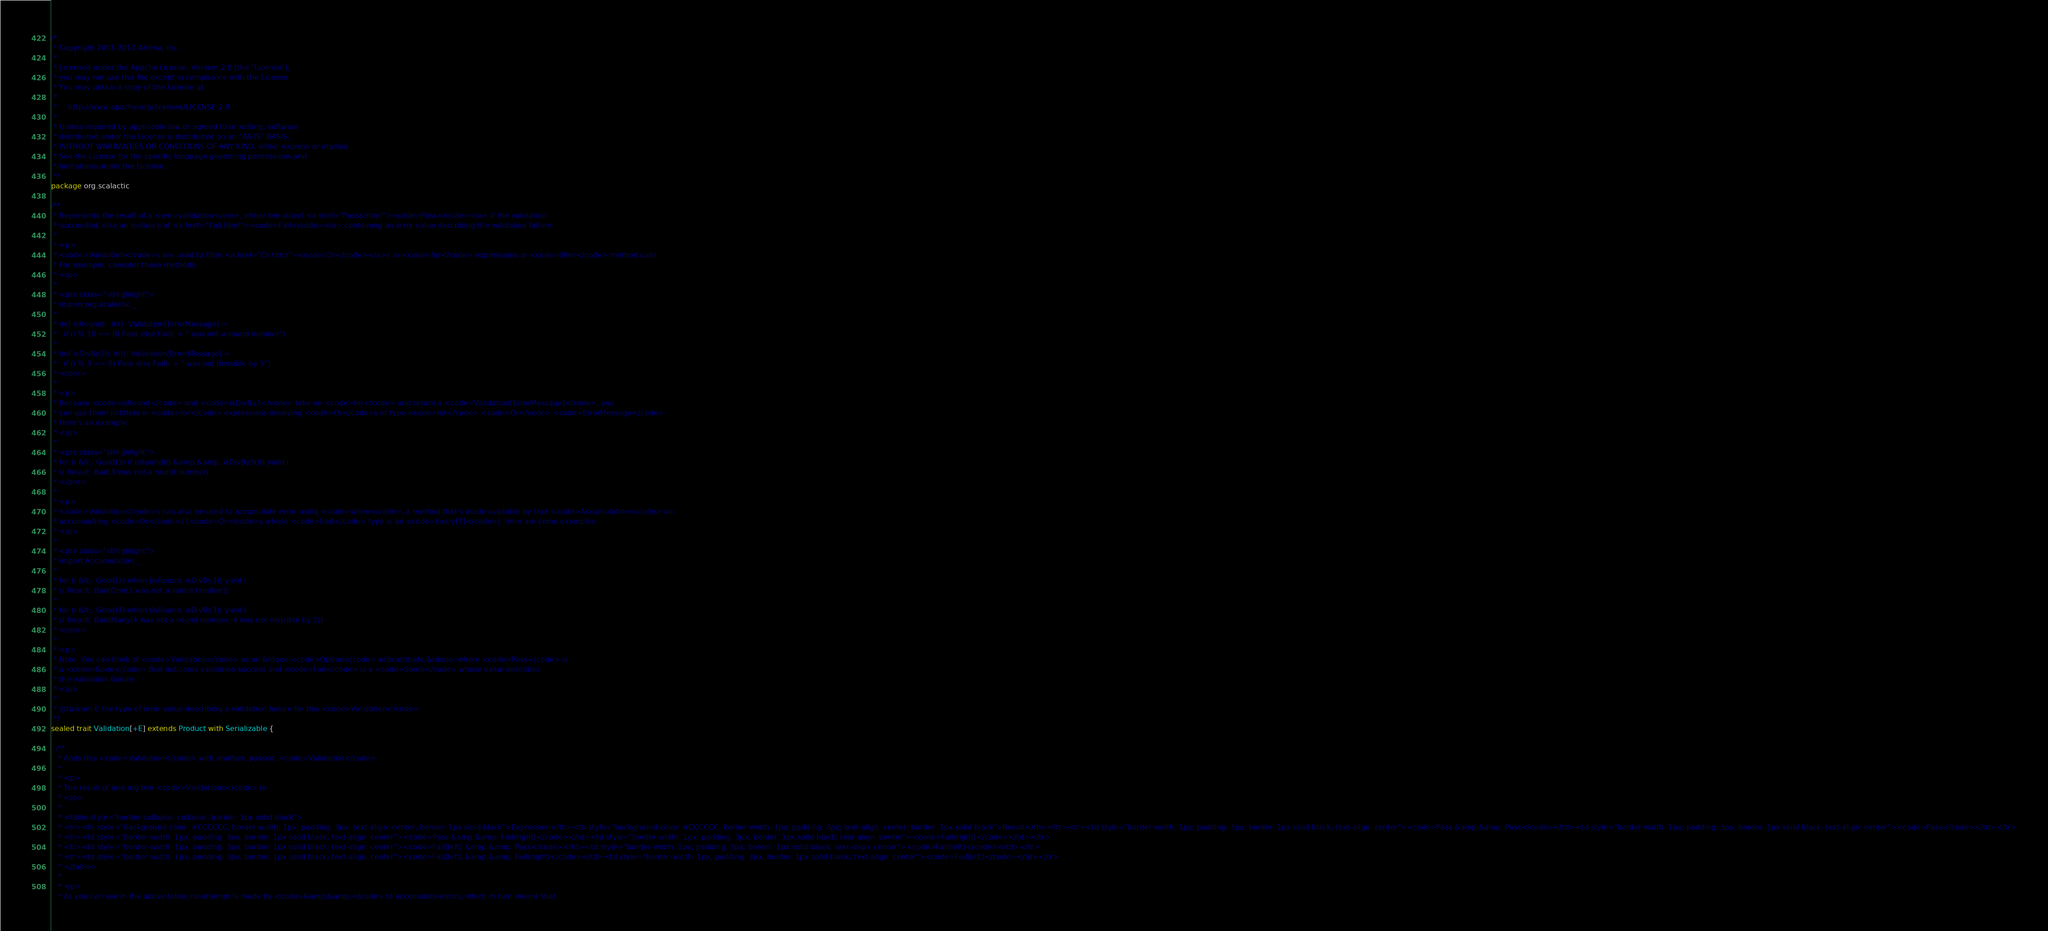<code> <loc_0><loc_0><loc_500><loc_500><_Scala_>/*
 * Copyright 2001-2013 Artima, Inc.
 *
 * Licensed under the Apache License, Version 2.0 (the "License");
 * you may not use this file except in compliance with the License.
 * You may obtain a copy of the License at
 *
 *     http://www.apache.org/licenses/LICENSE-2.0
 *
 * Unless required by applicable law or agreed to in writing, software
 * distributed under the License is distributed on an "AS IS" BASIS,
 * WITHOUT WARRANTIES OR CONDITIONS OF ANY KIND, either express or implied.
 * See the License for the specific language governing permissions and
 * limitations under the License.
 */
package org.scalactic

/**
 * Represents the result of a <em>validation</em>, either the object <a href="Pass$.html"><code>Pass</code></a> if the validation 
 * succeeded, else an instance of <a href="Fail.html"><code>Fail</code></a> containing an error value describing the validation failure.
 *
 * <p>
 * <code>Validation</code>s are used to filter <a href="Or.html"><code>Or</code></a>s in <code>for</code> expressions or <code>filter</code> method calls.
 * For example, consider these methods:
 * </p>
 *
 * <pre class="stHighlight">
 * import org.scalactic._
 *
 * def isRound(i: Int): Validation[ErrorMessage] =
 *   if (i % 10 == 0) Pass else Fail(i + " was not a round number")
 *
 * def isDivBy3(i: Int): Validation[ErrorMessage] =
 *   if (i % 3 == 0) Pass else Fail(i + " was not divisible by 3")
 * </pre>
 *
 * <p>
 * Because <code>isRound</code> and <code>isDivBy3</code> take an <code>Int</code> and return a <code>Validation[ErrorMessage]</code>, you
 * can use them in filters in <code>for</code> expressions involving <code>Or</code>s of type <code>Int</code> <code>Or</code> <code>ErrorMessage</code>.
 * Here's an example:
 * </p>
 *
 * <pre class="stHighlight">
 * for (i &lt;- Good(3) if isRound(i) &amp;&amp; isDivBy3(i)) yield i
 * // Result: Bad(3 was not a round number)
 * </pre>
 *
 * <p>
 * <code>Validation</code>s can also be used to accumulate error using <code>when</code>, a method that's made available by trait <code>Accumulation</code> on
 * accumualting <code>Or</code>s (<code>Or</code>s whose <code>Bad</code> type is an <code>Every[T]</code>). Here are some examples:
 * </p>
 *
 * <pre class="stHighlight">
 * import Accumulation._
 *
 * for (i &lt;- Good(3) when (isRound, isDivBy3)) yield i
 * // Result: Bad(One(3 was not a round number))
 *
 * for (i &lt;- Good(4) when (isRound, isDivBy3)) yield i
 * // Result: Bad(Many(4 was not a round number, 4 was not divisible by 3))
 * </pre>
 *
 * <p>
 * Note: You can think of <code>Validation</code> as an &ldquo;<code>Option</code> with attitude,&rdquo; where <code>Pass</code> is 
 * a <code>None</code> that indicates validation success and <code>Fail</code> is a <code>Some</code> whose value describes 
 * the validation failure.
 * </p>
 * 
 * @tparam E the type of error value describing a validation failure for this <code>Validation</code>
 */
sealed trait Validation[+E] extends Product with Serializable {

  /**
   * Ands this <code>Validation</code> with another, passed, <code>Validation</code>.
   *
   * <p>
   * The result of and-ing two <code>Validations</code> is:
   * </p>
   *
   * <table style="border-collapse: collapse; border: 1px solid black">
   * <tr><th style="background-color: #CCCCCC; border-width: 1px; padding: 3px; text-align: center; border: 1px solid black">Expression</th><th style="background-color: #CCCCCC; border-width: 1px; padding: 3px; text-align: center; border: 1px solid black">Result</th></tr><tr><td style="border-width: 1px; padding: 3px; border: 1px solid black; text-align: center"><code>Pass &amp;&amp; Pass</code></td><td style="border-width: 1px; padding: 3px; border: 1px solid black; text-align: center"><code>Pass</code></td></tr>
   * <tr><td style="border-width: 1px; padding: 3px; border: 1px solid black; text-align: center"><code>Pass &amp;&amp; Fail(right)</code></td><td style="border-width: 1px; padding: 3px; border: 1px solid black; text-align: center"><code>Fail(right)</code></td></tr>
   * <tr><td style="border-width: 1px; padding: 3px; border: 1px solid black; text-align: center"><code>Fail(left) &amp;&amp; Pass</code></td><td style="border-width: 1px; padding: 3px; border: 1px solid black; text-align: center"><code>Fail(left)</code></td></tr>
   * <tr><td style="border-width: 1px; padding: 3px; border: 1px solid black; text-align: center"><code>Fail(left) &amp;&amp; Fail(right)</code></td><td style="border-width: 1px; padding: 3px; border: 1px solid black; text-align: center"><code>Fail(left)</code></td></tr>
   * </table>
   *
   * <p>
   * As you can see in the above table, no attempt is made by <code>&amp;&amp;</code> to accumulate errors, which in turn means that</code> 